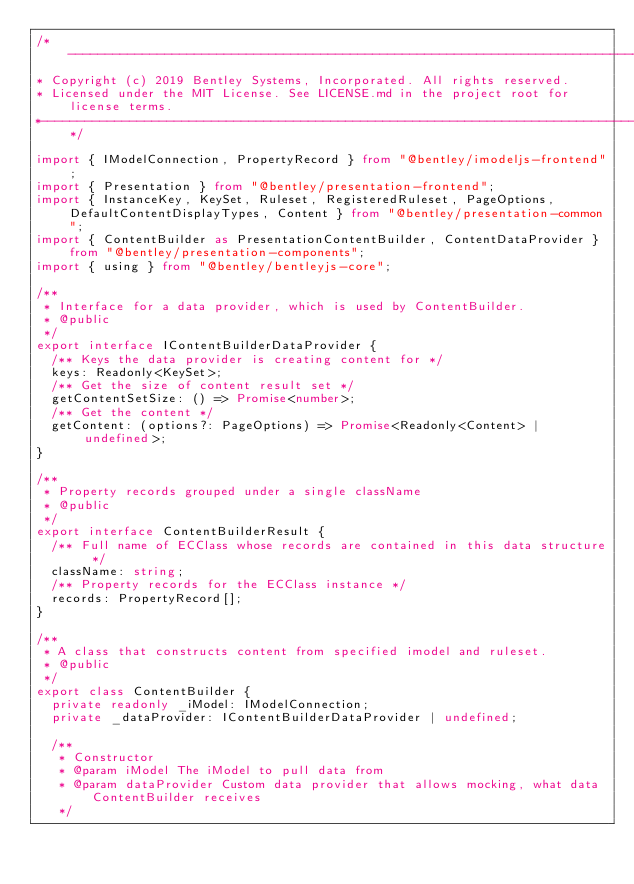Convert code to text. <code><loc_0><loc_0><loc_500><loc_500><_TypeScript_>/*---------------------------------------------------------------------------------------------
* Copyright (c) 2019 Bentley Systems, Incorporated. All rights reserved.
* Licensed under the MIT License. See LICENSE.md in the project root for license terms.
*--------------------------------------------------------------------------------------------*/

import { IModelConnection, PropertyRecord } from "@bentley/imodeljs-frontend";
import { Presentation } from "@bentley/presentation-frontend";
import { InstanceKey, KeySet, Ruleset, RegisteredRuleset, PageOptions, DefaultContentDisplayTypes, Content } from "@bentley/presentation-common";
import { ContentBuilder as PresentationContentBuilder, ContentDataProvider } from "@bentley/presentation-components";
import { using } from "@bentley/bentleyjs-core";

/**
 * Interface for a data provider, which is used by ContentBuilder.
 * @public
 */
export interface IContentBuilderDataProvider {
  /** Keys the data provider is creating content for */
  keys: Readonly<KeySet>;
  /** Get the size of content result set */
  getContentSetSize: () => Promise<number>;
  /** Get the content */
  getContent: (options?: PageOptions) => Promise<Readonly<Content> | undefined>;
}

/**
 * Property records grouped under a single className
 * @public
 */
export interface ContentBuilderResult {
  /** Full name of ECClass whose records are contained in this data structure */
  className: string;
  /** Property records for the ECClass instance */
  records: PropertyRecord[];
}

/**
 * A class that constructs content from specified imodel and ruleset.
 * @public
 */
export class ContentBuilder {
  private readonly _iModel: IModelConnection;
  private _dataProvider: IContentBuilderDataProvider | undefined;

  /**
   * Constructor
   * @param iModel The iModel to pull data from
   * @param dataProvider Custom data provider that allows mocking, what data ContentBuilder receives
   */</code> 